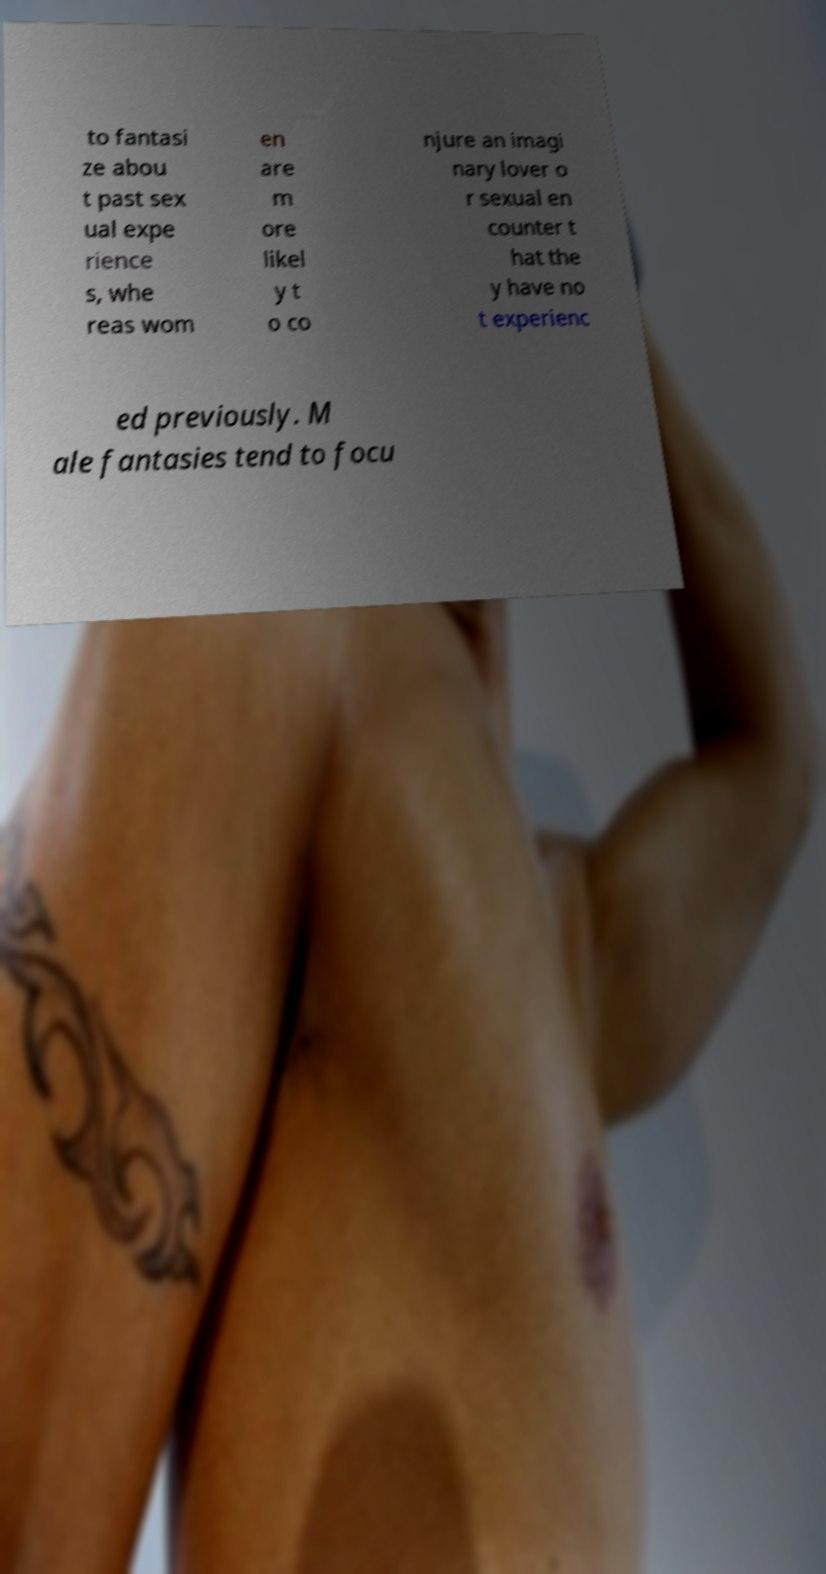Please identify and transcribe the text found in this image. to fantasi ze abou t past sex ual expe rience s, whe reas wom en are m ore likel y t o co njure an imagi nary lover o r sexual en counter t hat the y have no t experienc ed previously. M ale fantasies tend to focu 